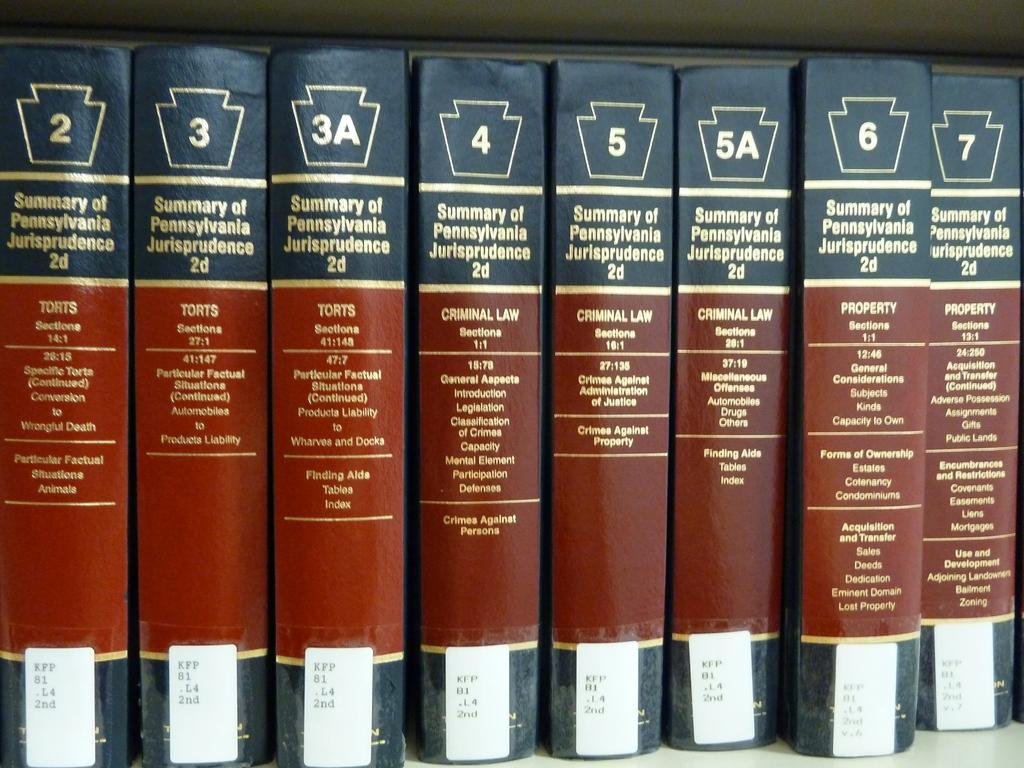<image>
Create a compact narrative representing the image presented. A range of dark blue and maroon books on Summary of Pennsylvania Jurisprudence volume 2, 3. 3A, 4 5, 5A, 6 and 7 